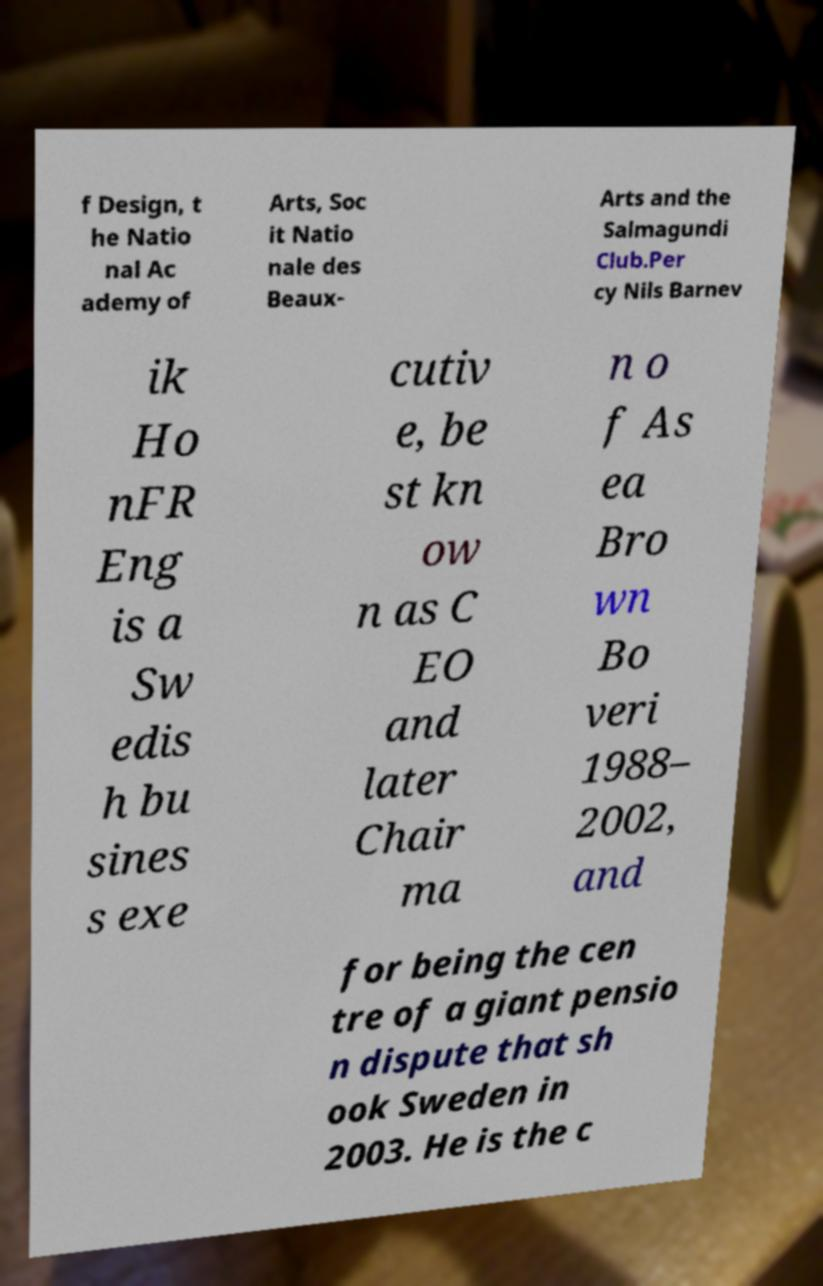Could you extract and type out the text from this image? f Design, t he Natio nal Ac ademy of Arts, Soc it Natio nale des Beaux- Arts and the Salmagundi Club.Per cy Nils Barnev ik Ho nFR Eng is a Sw edis h bu sines s exe cutiv e, be st kn ow n as C EO and later Chair ma n o f As ea Bro wn Bo veri 1988– 2002, and for being the cen tre of a giant pensio n dispute that sh ook Sweden in 2003. He is the c 